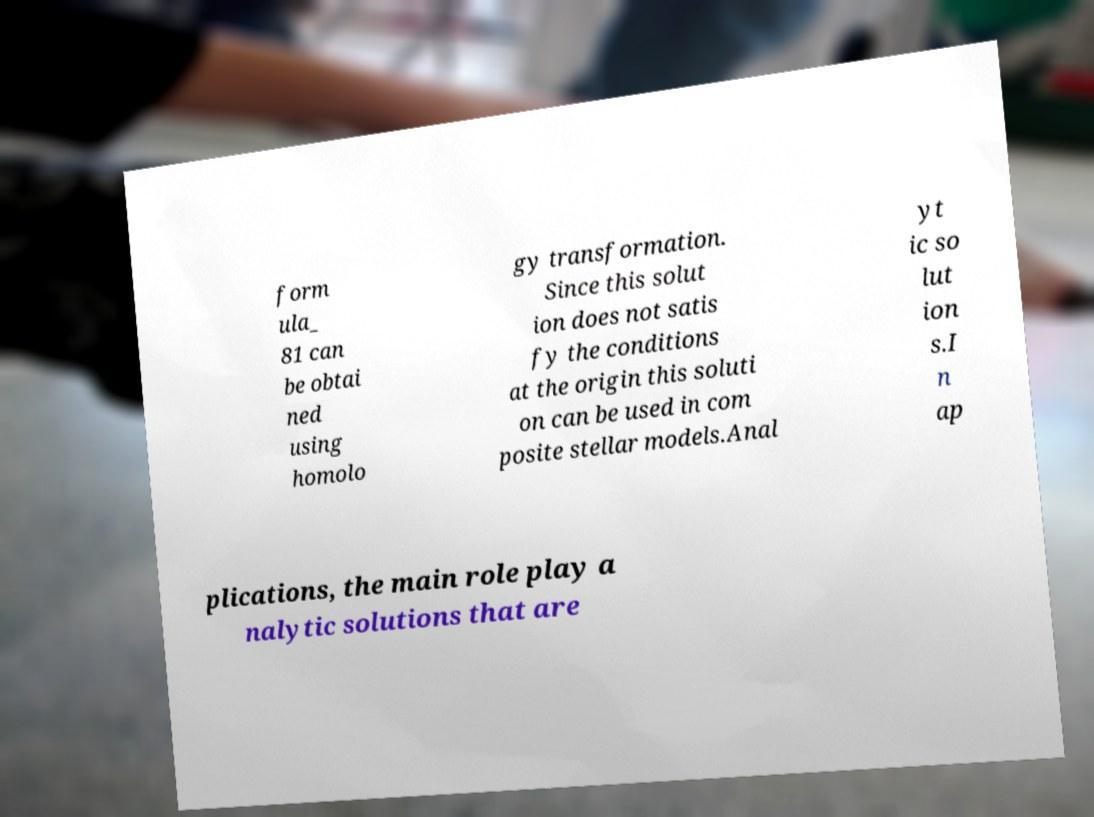I need the written content from this picture converted into text. Can you do that? form ula_ 81 can be obtai ned using homolo gy transformation. Since this solut ion does not satis fy the conditions at the origin this soluti on can be used in com posite stellar models.Anal yt ic so lut ion s.I n ap plications, the main role play a nalytic solutions that are 